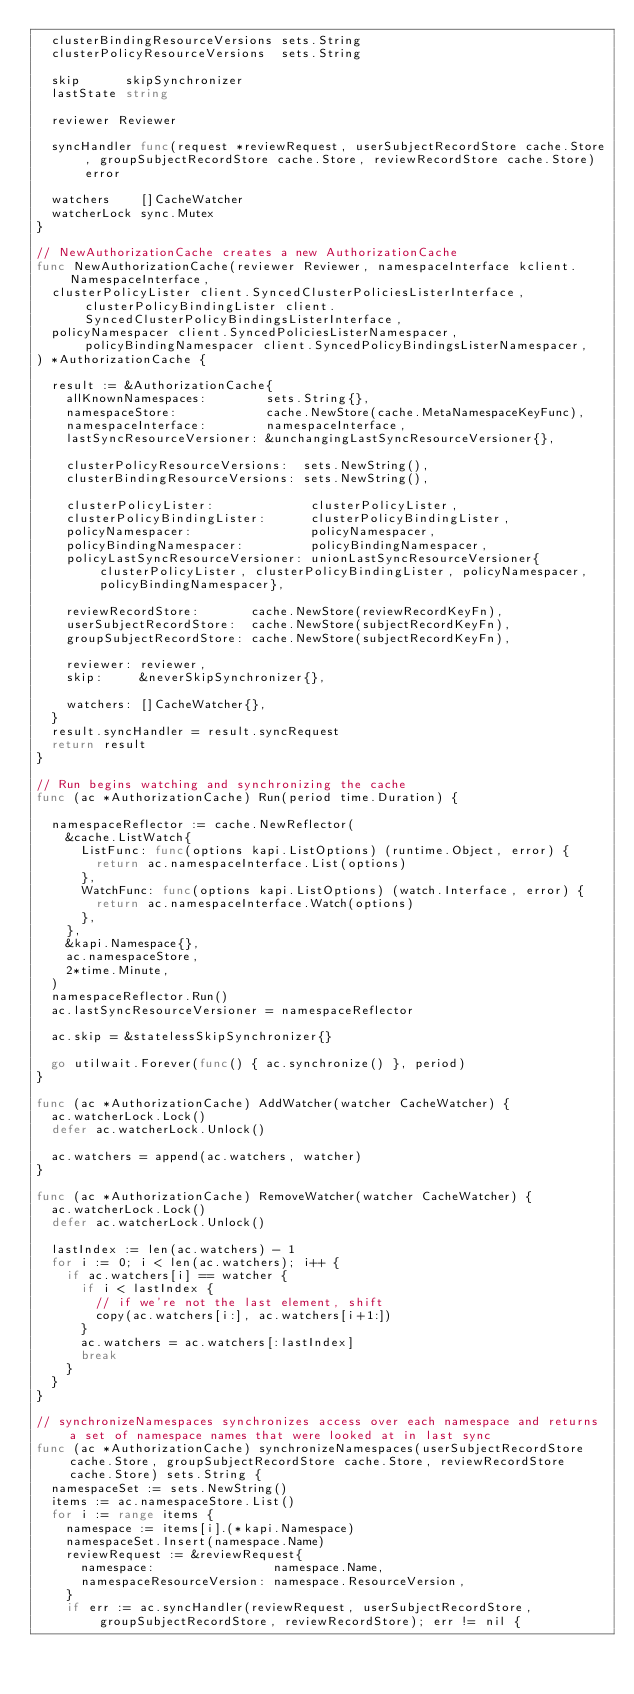<code> <loc_0><loc_0><loc_500><loc_500><_Go_>	clusterBindingResourceVersions sets.String
	clusterPolicyResourceVersions  sets.String

	skip      skipSynchronizer
	lastState string

	reviewer Reviewer

	syncHandler func(request *reviewRequest, userSubjectRecordStore cache.Store, groupSubjectRecordStore cache.Store, reviewRecordStore cache.Store) error

	watchers    []CacheWatcher
	watcherLock sync.Mutex
}

// NewAuthorizationCache creates a new AuthorizationCache
func NewAuthorizationCache(reviewer Reviewer, namespaceInterface kclient.NamespaceInterface,
	clusterPolicyLister client.SyncedClusterPoliciesListerInterface, clusterPolicyBindingLister client.SyncedClusterPolicyBindingsListerInterface,
	policyNamespacer client.SyncedPoliciesListerNamespacer, policyBindingNamespacer client.SyncedPolicyBindingsListerNamespacer,
) *AuthorizationCache {

	result := &AuthorizationCache{
		allKnownNamespaces:        sets.String{},
		namespaceStore:            cache.NewStore(cache.MetaNamespaceKeyFunc),
		namespaceInterface:        namespaceInterface,
		lastSyncResourceVersioner: &unchangingLastSyncResourceVersioner{},

		clusterPolicyResourceVersions:  sets.NewString(),
		clusterBindingResourceVersions: sets.NewString(),

		clusterPolicyLister:             clusterPolicyLister,
		clusterPolicyBindingLister:      clusterPolicyBindingLister,
		policyNamespacer:                policyNamespacer,
		policyBindingNamespacer:         policyBindingNamespacer,
		policyLastSyncResourceVersioner: unionLastSyncResourceVersioner{clusterPolicyLister, clusterPolicyBindingLister, policyNamespacer, policyBindingNamespacer},

		reviewRecordStore:       cache.NewStore(reviewRecordKeyFn),
		userSubjectRecordStore:  cache.NewStore(subjectRecordKeyFn),
		groupSubjectRecordStore: cache.NewStore(subjectRecordKeyFn),

		reviewer: reviewer,
		skip:     &neverSkipSynchronizer{},

		watchers: []CacheWatcher{},
	}
	result.syncHandler = result.syncRequest
	return result
}

// Run begins watching and synchronizing the cache
func (ac *AuthorizationCache) Run(period time.Duration) {

	namespaceReflector := cache.NewReflector(
		&cache.ListWatch{
			ListFunc: func(options kapi.ListOptions) (runtime.Object, error) {
				return ac.namespaceInterface.List(options)
			},
			WatchFunc: func(options kapi.ListOptions) (watch.Interface, error) {
				return ac.namespaceInterface.Watch(options)
			},
		},
		&kapi.Namespace{},
		ac.namespaceStore,
		2*time.Minute,
	)
	namespaceReflector.Run()
	ac.lastSyncResourceVersioner = namespaceReflector

	ac.skip = &statelessSkipSynchronizer{}

	go utilwait.Forever(func() { ac.synchronize() }, period)
}

func (ac *AuthorizationCache) AddWatcher(watcher CacheWatcher) {
	ac.watcherLock.Lock()
	defer ac.watcherLock.Unlock()

	ac.watchers = append(ac.watchers, watcher)
}

func (ac *AuthorizationCache) RemoveWatcher(watcher CacheWatcher) {
	ac.watcherLock.Lock()
	defer ac.watcherLock.Unlock()

	lastIndex := len(ac.watchers) - 1
	for i := 0; i < len(ac.watchers); i++ {
		if ac.watchers[i] == watcher {
			if i < lastIndex {
				// if we're not the last element, shift
				copy(ac.watchers[i:], ac.watchers[i+1:])
			}
			ac.watchers = ac.watchers[:lastIndex]
			break
		}
	}
}

// synchronizeNamespaces synchronizes access over each namespace and returns a set of namespace names that were looked at in last sync
func (ac *AuthorizationCache) synchronizeNamespaces(userSubjectRecordStore cache.Store, groupSubjectRecordStore cache.Store, reviewRecordStore cache.Store) sets.String {
	namespaceSet := sets.NewString()
	items := ac.namespaceStore.List()
	for i := range items {
		namespace := items[i].(*kapi.Namespace)
		namespaceSet.Insert(namespace.Name)
		reviewRequest := &reviewRequest{
			namespace:                namespace.Name,
			namespaceResourceVersion: namespace.ResourceVersion,
		}
		if err := ac.syncHandler(reviewRequest, userSubjectRecordStore, groupSubjectRecordStore, reviewRecordStore); err != nil {</code> 